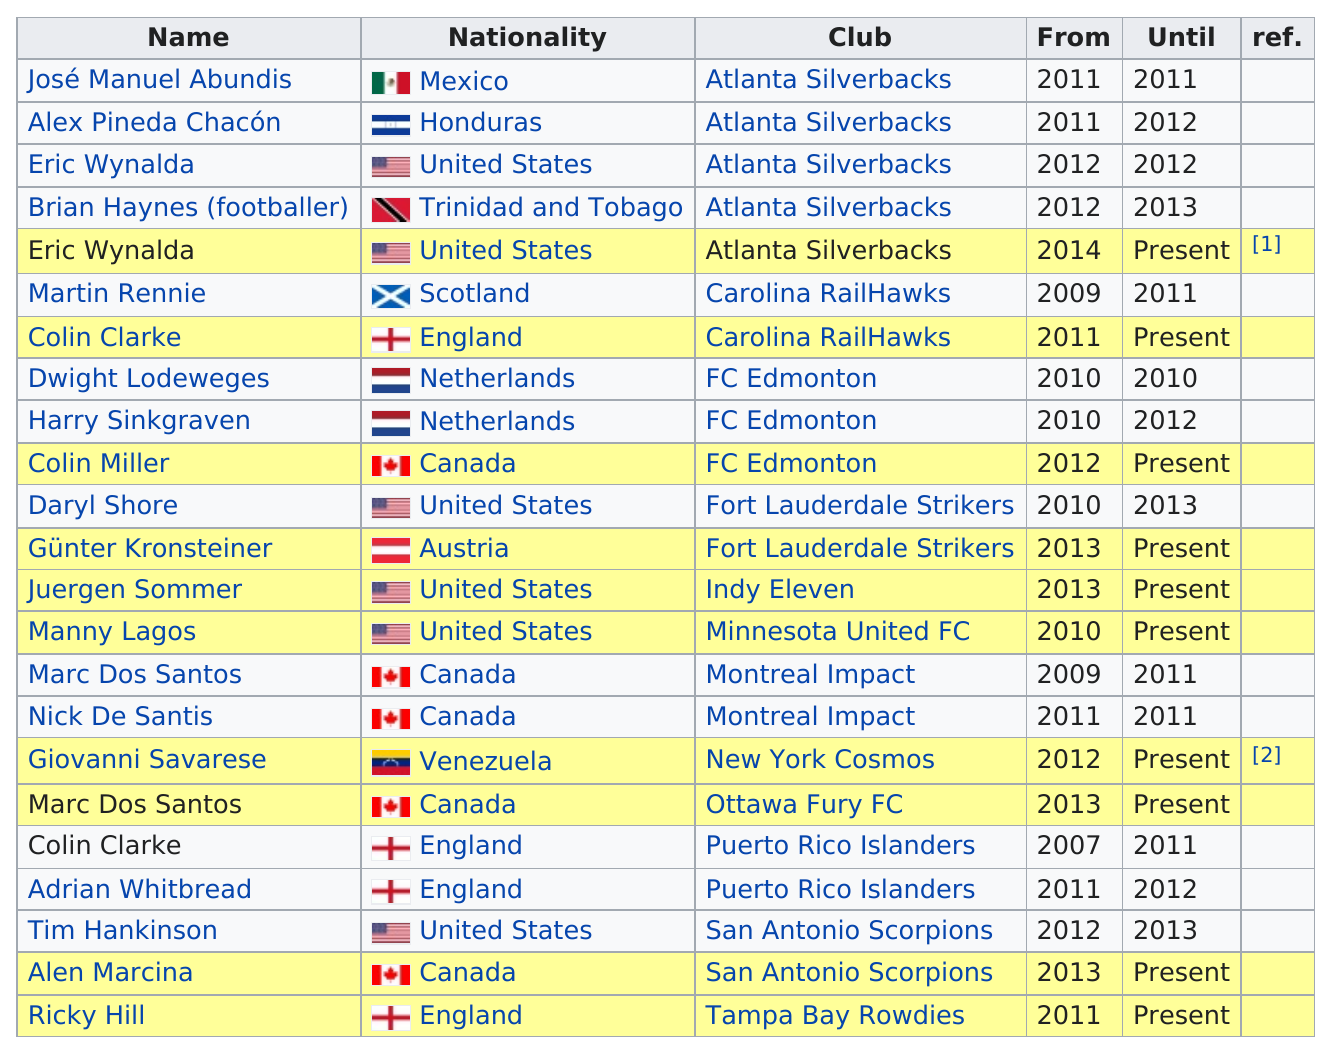Mention a couple of crucial points in this snapshot. Colin Clarke coached the Puerto Rico Islanders for a period of 4 years. Many coaches from America have coached, with six of them in total. It is declared that Colin Clarke coached the Puerto Rico Islanders for a period of 4 years. Abundis coached the Silverbacks for a longer period of time than Chacon did. Chacon coached the Silverbacks for a shorter period of time. For a period of three years, Daryl Shore served as the coach of the Strikers. 